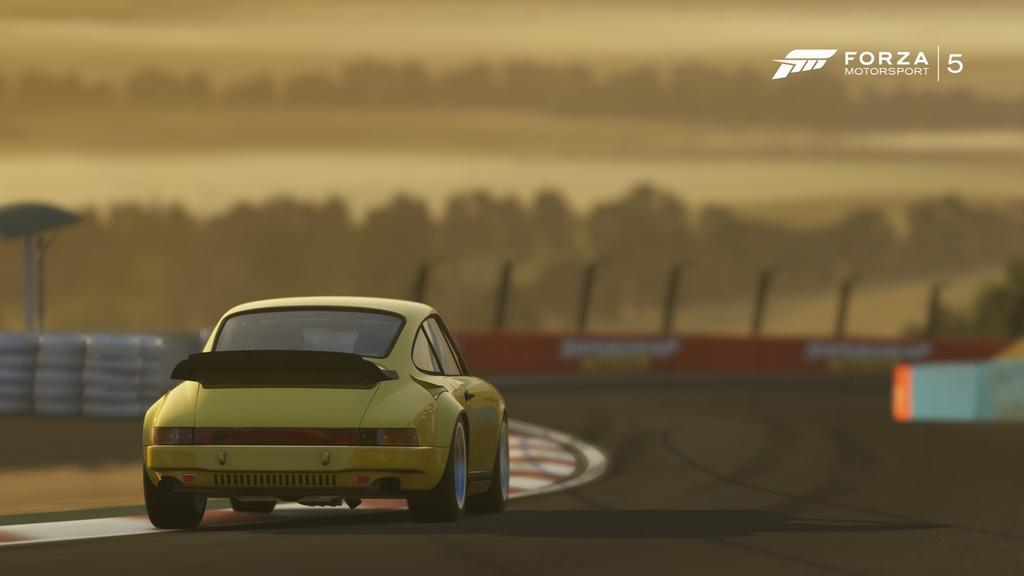What is the main subject of the image? There is a car in the image. What is the car doing in the image? The car is moving on the road. Is there any text present in the image? Yes, there is text visible in the top right side of the image. How would you describe the background of the image? The background of the image is blurred. Can you see any cats playing on the sidewalk in the image? There is no sidewalk or cat present in the image. Is the car driving through snow in the image? There is no snow present in the image. 